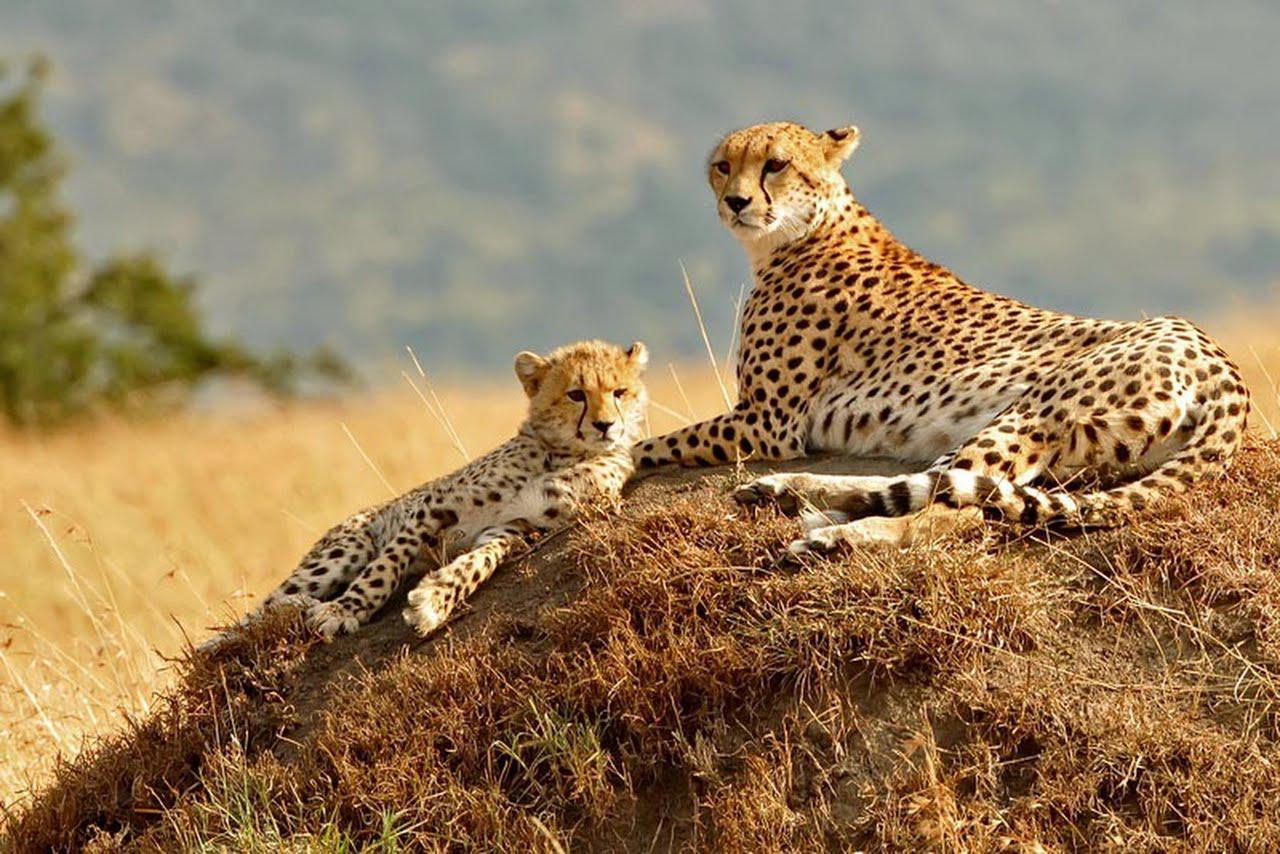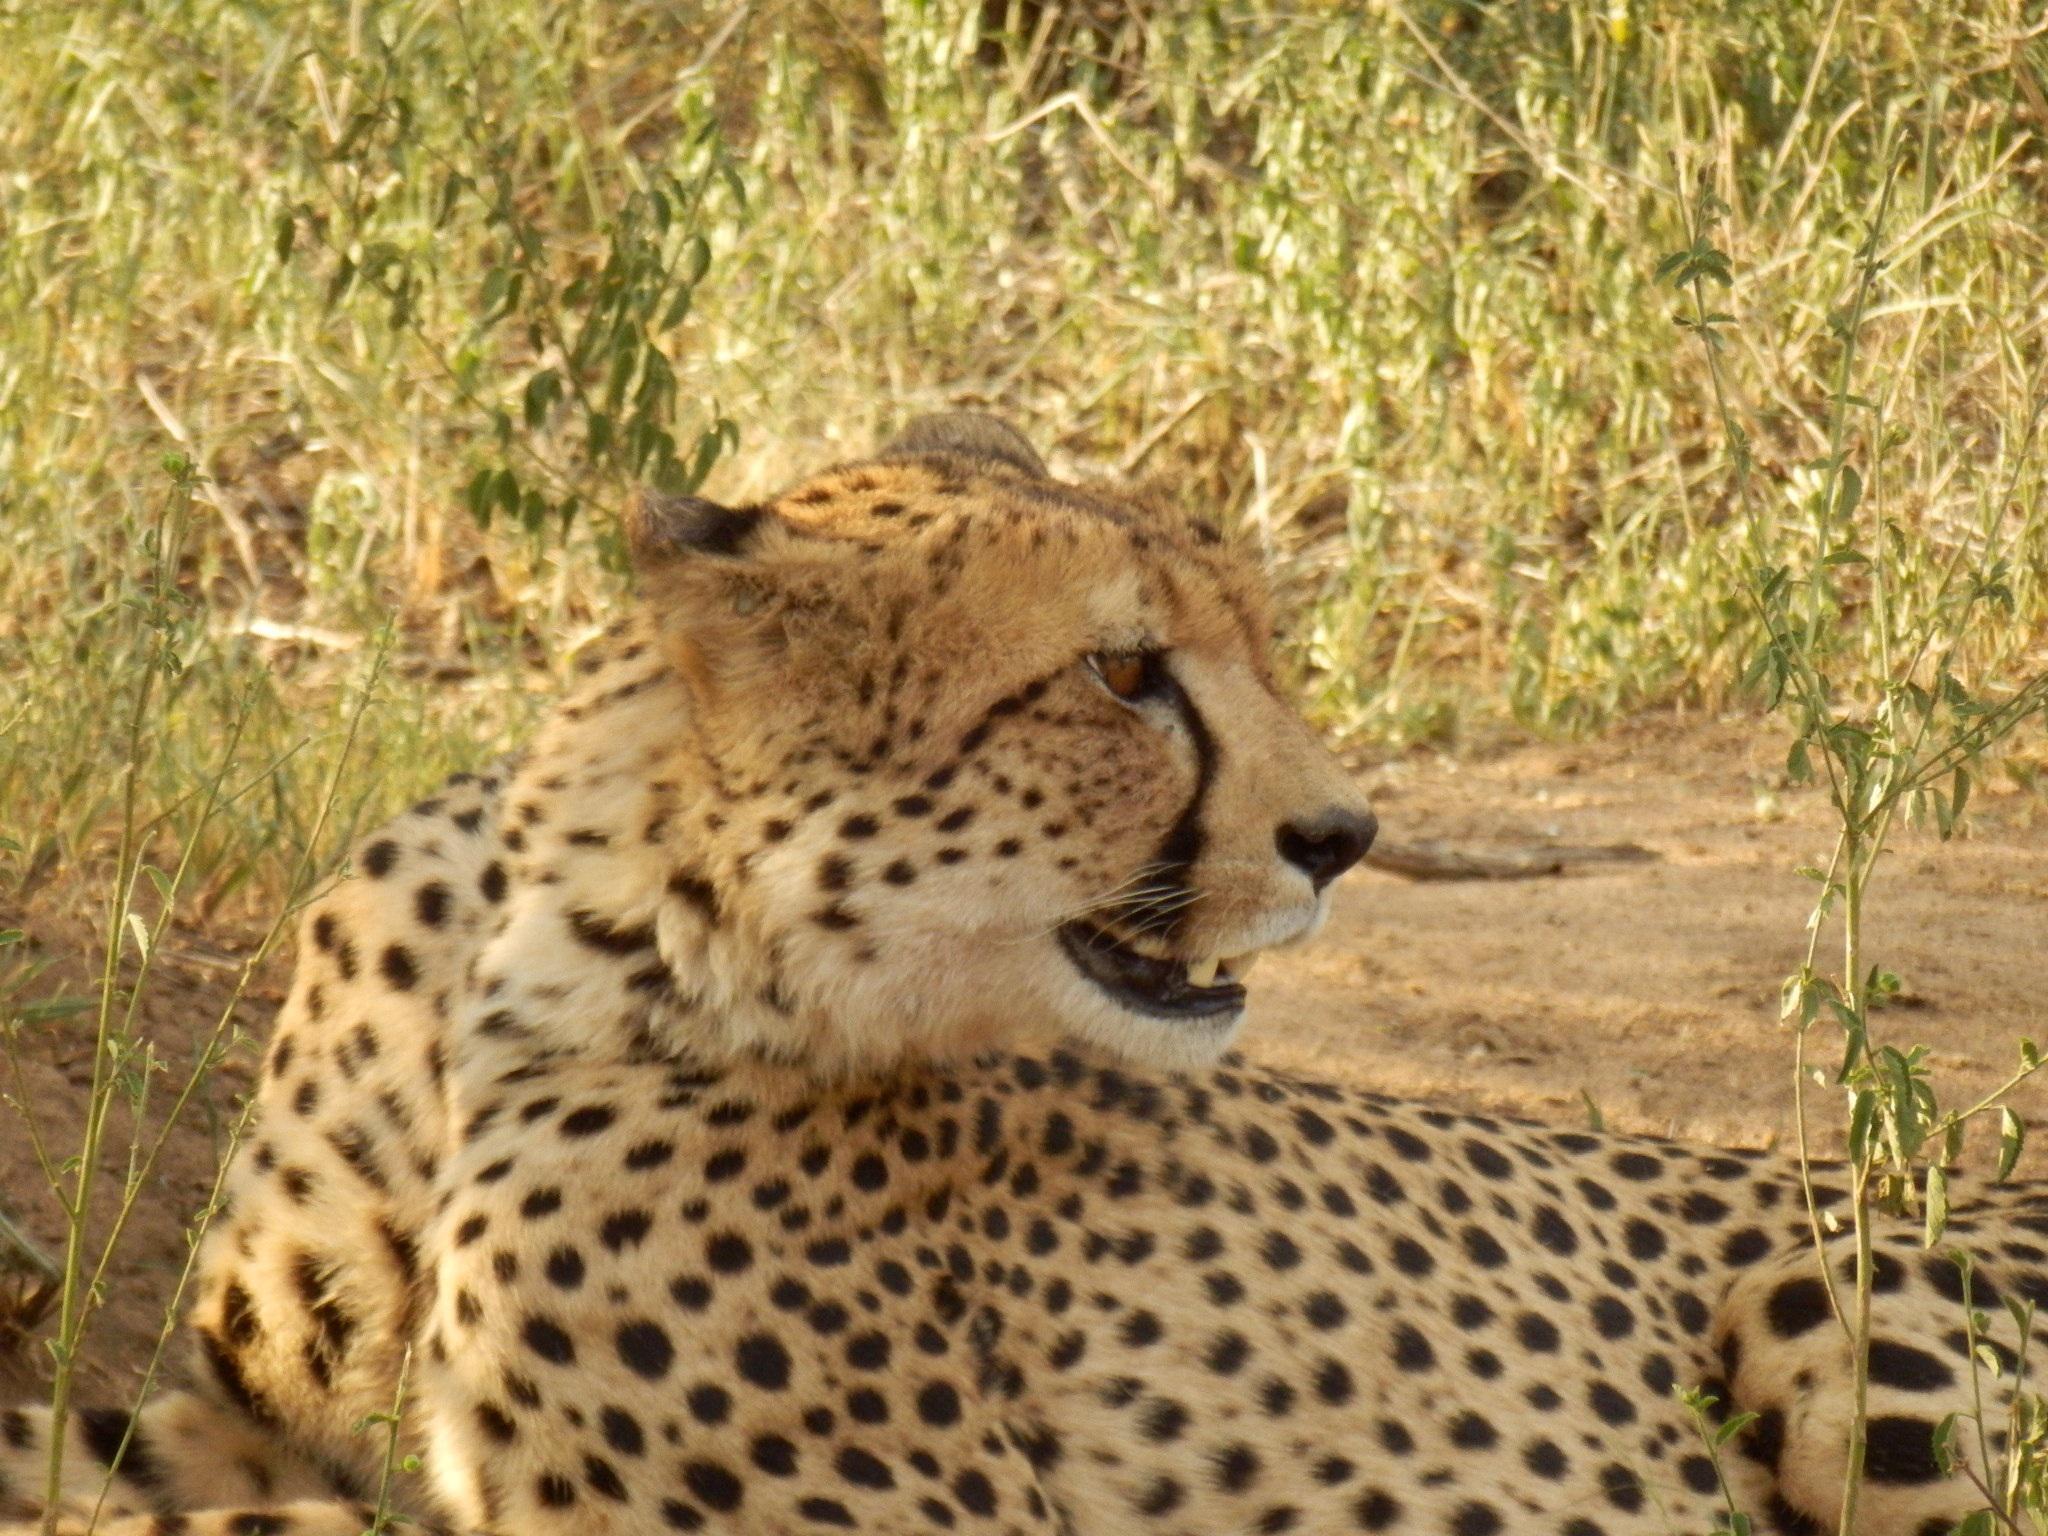The first image is the image on the left, the second image is the image on the right. Considering the images on both sides, is "The left image contains exactly two cheetahs." valid? Answer yes or no. Yes. The first image is the image on the left, the second image is the image on the right. Analyze the images presented: Is the assertion "The right image contains half as many cheetahs as the left image." valid? Answer yes or no. Yes. 